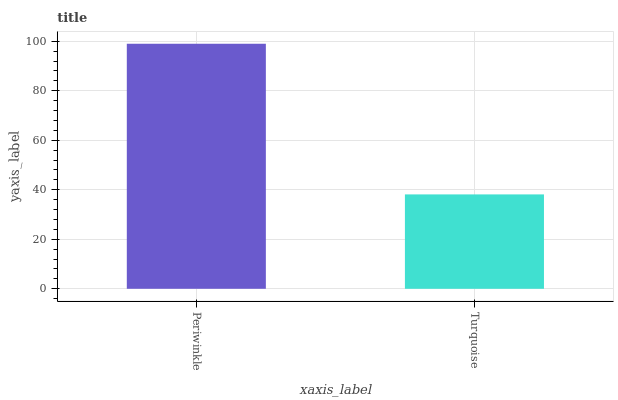Is Turquoise the minimum?
Answer yes or no. Yes. Is Periwinkle the maximum?
Answer yes or no. Yes. Is Turquoise the maximum?
Answer yes or no. No. Is Periwinkle greater than Turquoise?
Answer yes or no. Yes. Is Turquoise less than Periwinkle?
Answer yes or no. Yes. Is Turquoise greater than Periwinkle?
Answer yes or no. No. Is Periwinkle less than Turquoise?
Answer yes or no. No. Is Periwinkle the high median?
Answer yes or no. Yes. Is Turquoise the low median?
Answer yes or no. Yes. Is Turquoise the high median?
Answer yes or no. No. Is Periwinkle the low median?
Answer yes or no. No. 